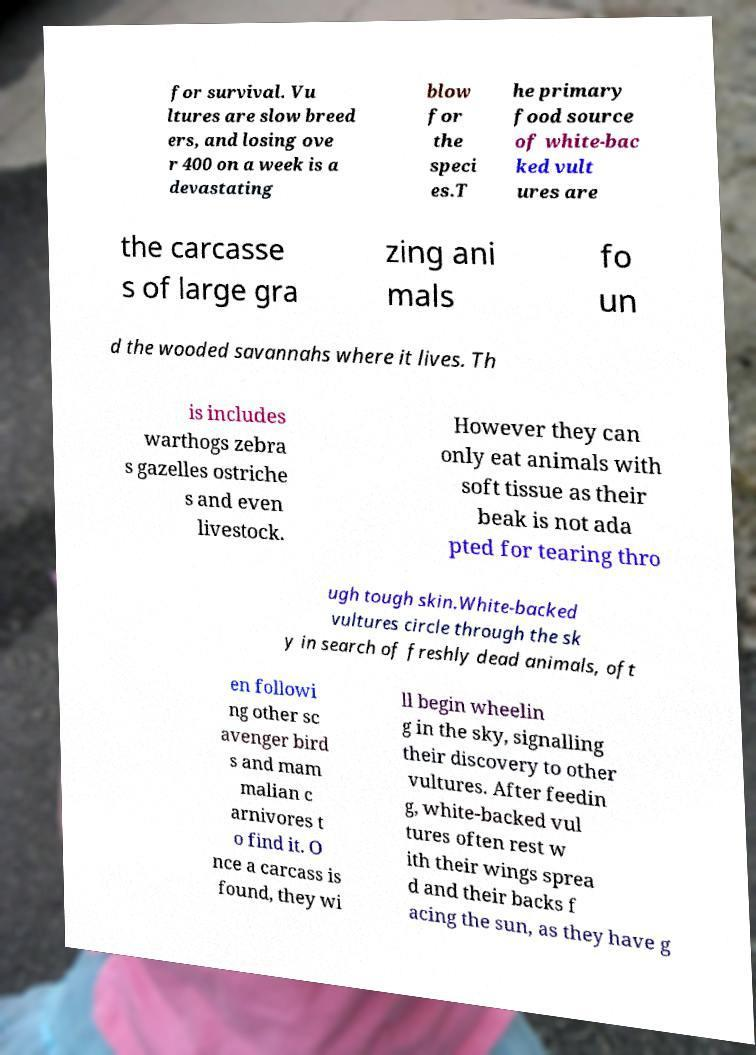Could you extract and type out the text from this image? for survival. Vu ltures are slow breed ers, and losing ove r 400 on a week is a devastating blow for the speci es.T he primary food source of white-bac ked vult ures are the carcasse s of large gra zing ani mals fo un d the wooded savannahs where it lives. Th is includes warthogs zebra s gazelles ostriche s and even livestock. However they can only eat animals with soft tissue as their beak is not ada pted for tearing thro ugh tough skin.White-backed vultures circle through the sk y in search of freshly dead animals, oft en followi ng other sc avenger bird s and mam malian c arnivores t o find it. O nce a carcass is found, they wi ll begin wheelin g in the sky, signalling their discovery to other vultures. After feedin g, white-backed vul tures often rest w ith their wings sprea d and their backs f acing the sun, as they have g 